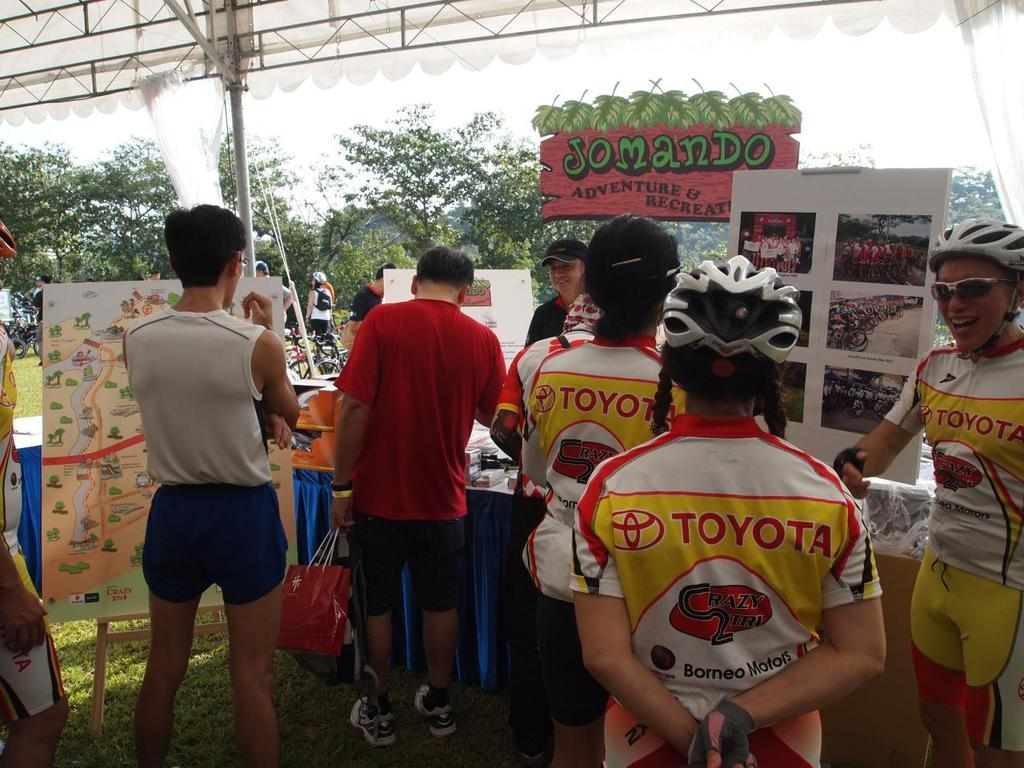<image>
Describe the image concisely. A group of people wearing Toyota shirts are gathered outside of Jomando Adventure and Recreation Park. 